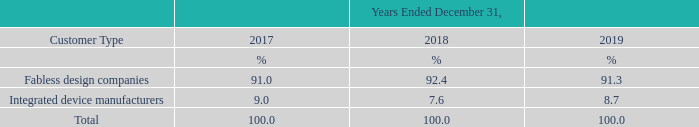We believe our success in attracting these end customers is a direct result of our commitment to high quality service and our intense focus on customer needs and performance. As an independent semiconductor foundry, most of our operating revenue is generated by our sales of wafers. The following table presented the percentages of our wafer sales by types of customers for the years ended December 31, 2017, 2018 and 2019.
We focus on providing a high level of customer service in order to attract customers and maintain their ongoing loyalty. Our culture emphasizes responsiveness to customer needs with a focus on flexibility, speed and accuracy throughout our manufacturing and delivery processes. Our customer oriented approach is especially evident in two types of services: customer design development services and manufacturing services.
For example, in 2013, we expand our regional business by opening our UMC Korea office, in order to provide local support to our customers in Korea, and shorten time-to-market for our Korea-based customers designing and manufacturing on UMC process technologies. We believe that our large production capacity and advanced process technology enable us to provide better customer service than many other foundries through shorter turn-around time, greater manufacturing flexibility and higher manufacturing yields.
What does the company culture emphasize on? Our culture emphasizes responsiveness to customer needs with a focus on flexibility, speed and accuracy throughout our manufacturing and delivery processes. What is the major portion of the operating revenue? Wafers. What is the approach taken by the company to grow its business? Our customer oriented approach is especially evident in two types of services: customer design development services and manufacturing services. What is the increase / (decrease) in the Fabless design companies from 2018 to 2019?
Answer scale should be: percent. 91.3% - 92.4%
Answer: -1.1. What is the average of Integrated device manufacturers?
Answer scale should be: percent. (9.0% + 7.6% + 8.7%) / 3
Answer: 8.43. What is the increase / (decrease) in the Integrated device manufacturers from 2017 to 2018?
Answer scale should be: percent. 7.6% - 9.0%
Answer: -1.4. 